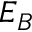Convert formula to latex. <formula><loc_0><loc_0><loc_500><loc_500>E _ { B }</formula> 